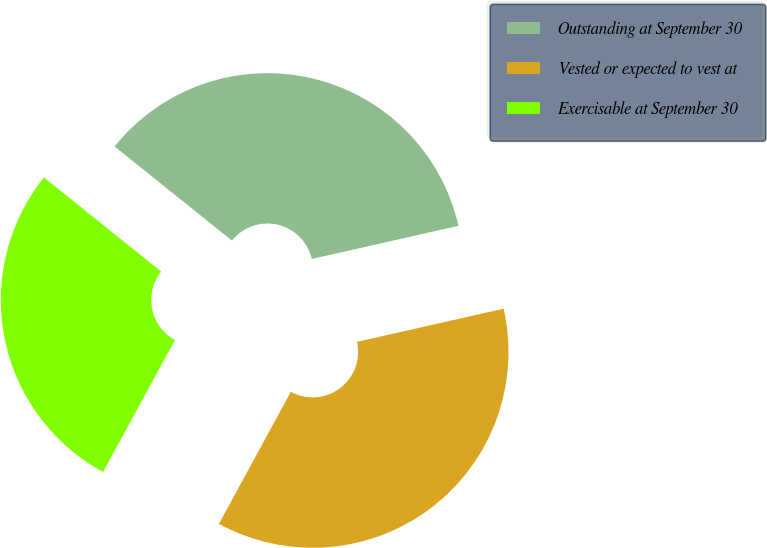<chart> <loc_0><loc_0><loc_500><loc_500><pie_chart><fcel>Outstanding at September 30<fcel>Vested or expected to vest at<fcel>Exercisable at September 30<nl><fcel>35.7%<fcel>36.48%<fcel>27.82%<nl></chart> 